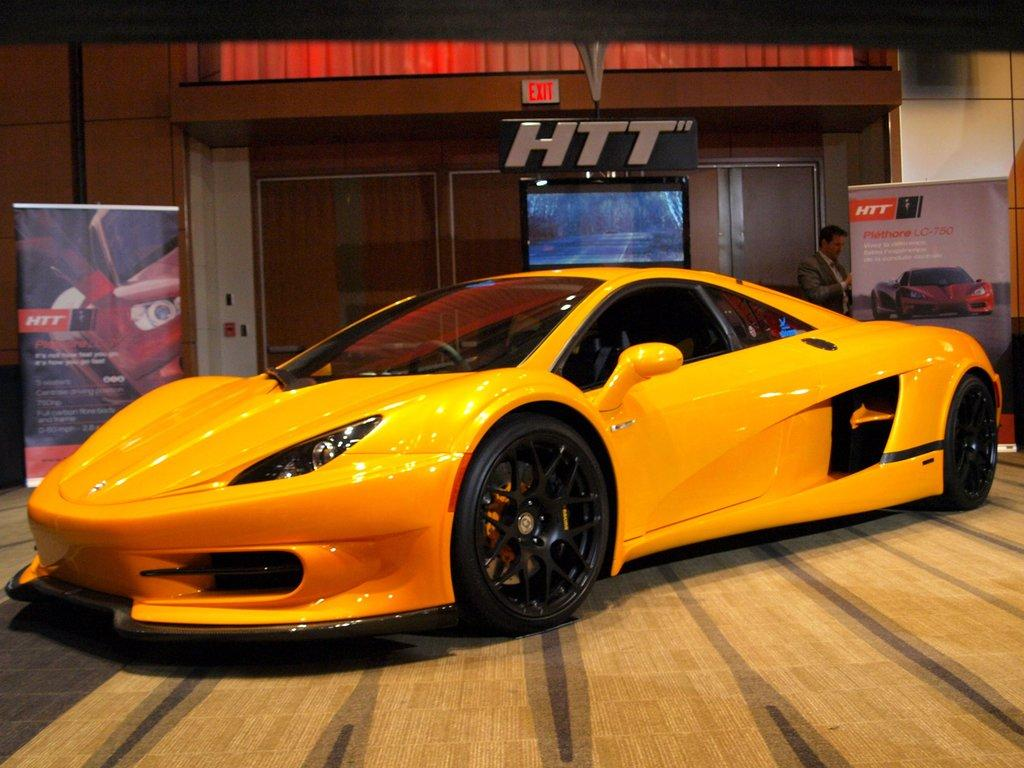What color is the car in the foreground of the image? The car in the foreground of the image is yellow. What is the car resting on in the image? The car is on a surface in the image. What can be seen in the background of the image? In the background of the image, there are banners, a wall, a person, and a screen. What type of thunder can be heard in the image? There is no thunder present in the image, as it is a still photograph. 